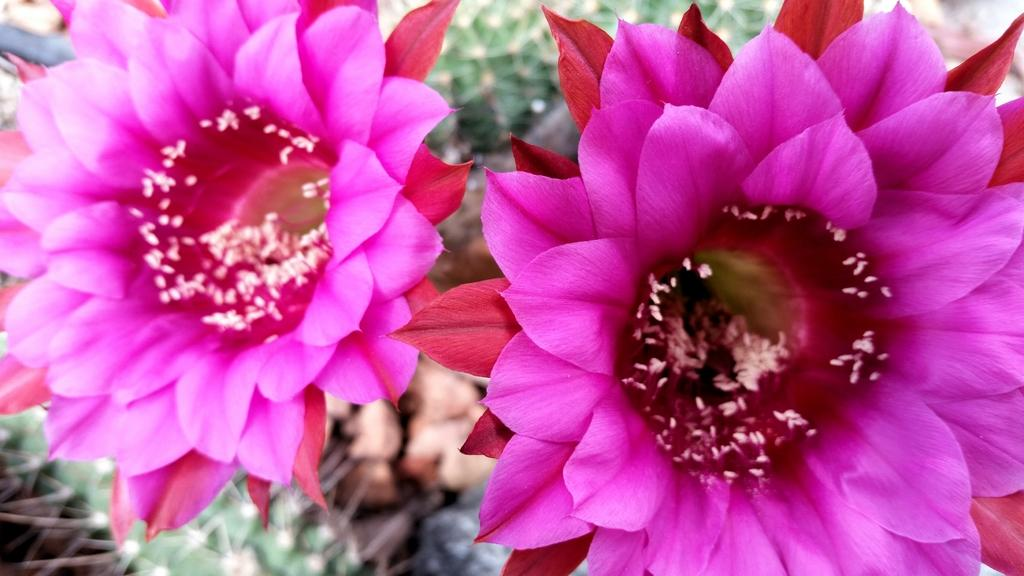What type of flowers can be seen in the image? There are two pink color flowers in the image. Can you describe the background of the image? The background of the image is blurred. What type of houses can be seen in the background of the image? There are no houses visible in the image; only the two pink color flowers and a blurred background are present. What does the earth smell like in the image? The image does not depict any scents or smells, so it is not possible to determine the smell of the earth in the image. 